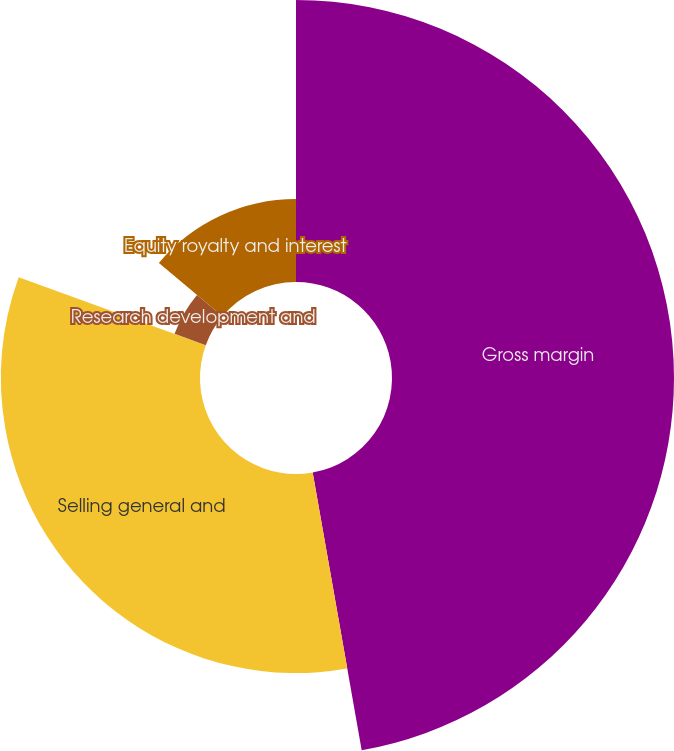<chart> <loc_0><loc_0><loc_500><loc_500><pie_chart><fcel>Gross margin<fcel>Selling general and<fcel>Research development and<fcel>Equity royalty and interest<nl><fcel>47.22%<fcel>33.33%<fcel>5.56%<fcel>13.89%<nl></chart> 